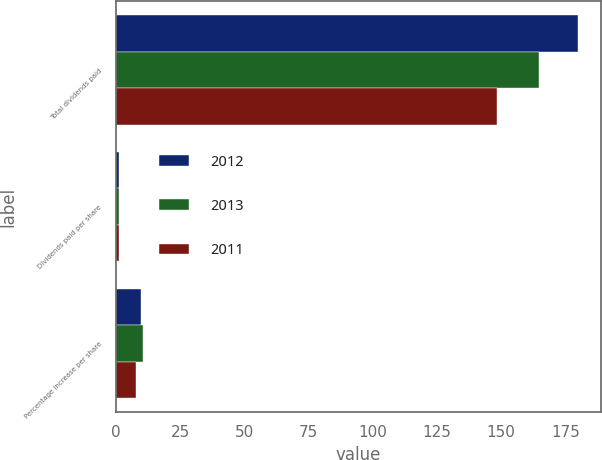<chart> <loc_0><loc_0><loc_500><loc_500><stacked_bar_chart><ecel><fcel>Total dividends paid<fcel>Dividends paid per share<fcel>Percentage increase per share<nl><fcel>2012<fcel>179.9<fcel>1.36<fcel>9.7<nl><fcel>2013<fcel>164.7<fcel>1.24<fcel>10.7<nl><fcel>2011<fcel>148.5<fcel>1.12<fcel>7.7<nl></chart> 